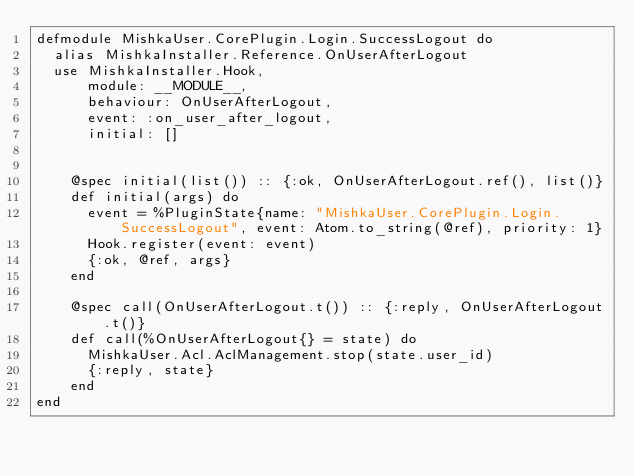<code> <loc_0><loc_0><loc_500><loc_500><_Elixir_>defmodule MishkaUser.CorePlugin.Login.SuccessLogout do
  alias MishkaInstaller.Reference.OnUserAfterLogout
  use MishkaInstaller.Hook,
      module: __MODULE__,
      behaviour: OnUserAfterLogout,
      event: :on_user_after_logout,
      initial: []


    @spec initial(list()) :: {:ok, OnUserAfterLogout.ref(), list()}
    def initial(args) do
      event = %PluginState{name: "MishkaUser.CorePlugin.Login.SuccessLogout", event: Atom.to_string(@ref), priority: 1}
      Hook.register(event: event)
      {:ok, @ref, args}
    end

    @spec call(OnUserAfterLogout.t()) :: {:reply, OnUserAfterLogout.t()}
    def call(%OnUserAfterLogout{} = state) do
      MishkaUser.Acl.AclManagement.stop(state.user_id)
      {:reply, state}
    end
end
</code> 